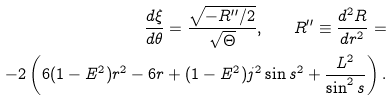Convert formula to latex. <formula><loc_0><loc_0><loc_500><loc_500>\frac { d \xi } { d \theta } = \frac { \sqrt { - R ^ { \prime \prime } / 2 } } { \sqrt { \Theta } } , \quad R ^ { \prime \prime } \equiv \frac { d ^ { 2 } R } { d r ^ { 2 } } = \\ - 2 \left ( 6 ( 1 - E ^ { 2 } ) r ^ { 2 } - 6 r + ( 1 - E ^ { 2 } ) j ^ { 2 } \sin { s } ^ { 2 } + \frac { L ^ { 2 } } { \sin ^ { 2 } { s } } \right ) .</formula> 